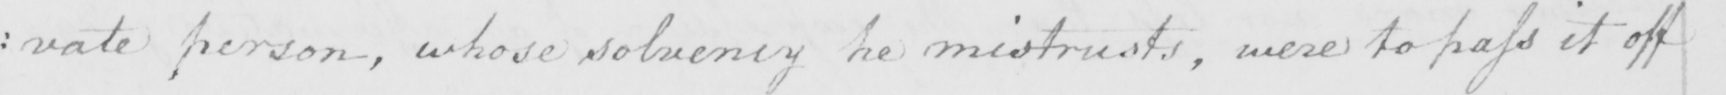Can you read and transcribe this handwriting? : vate person , whose solvency he mistrusts , were to pass it off 